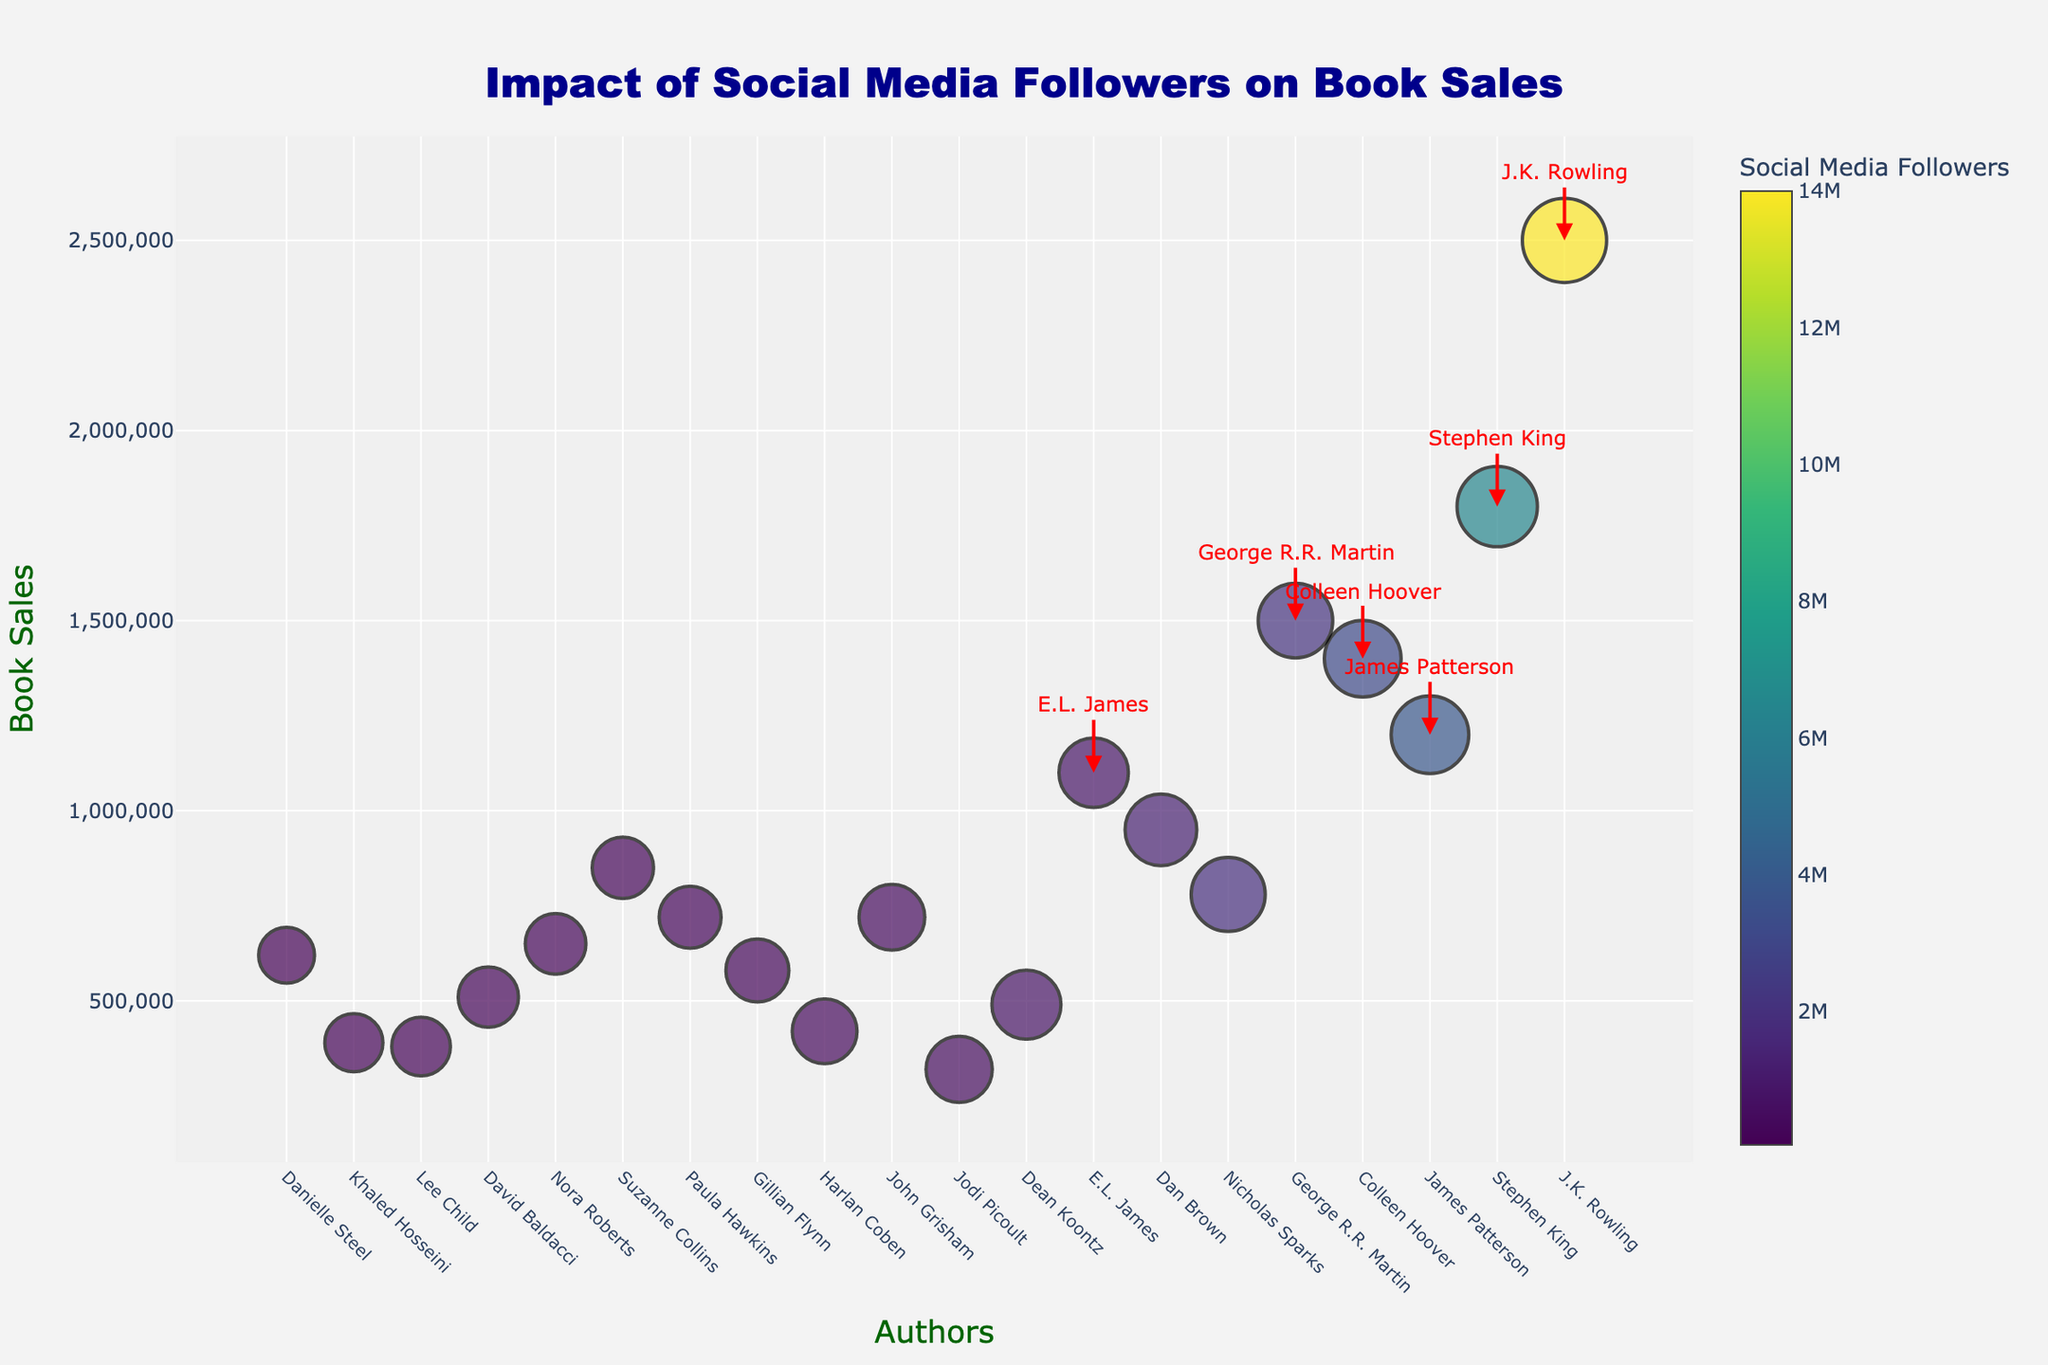What's the title of the plot? The title of the plot is displayed at the top and reads 'Impact of Social Media Followers on Book Sales'.
Answer: Impact of Social Media Followers on Book Sales How many authors have book sales over 1,000,000? To determine this, we look at data points above the 1,000,000 mark on the y-axis. These authors are highlighted with annotations. There are 7 authors with sales over 1,000,000.
Answer: 7 Which author has the highest social media follower count? The size and color intensity in the figure indicate higher social media follower counts. The author with the largest and most intense color marker, along with the highest count annotation, is J.K. Rowling.
Answer: J.K. Rowling What is the y-axis label in the plot? The label of the y-axis can be seen along the vertical axis, which reads 'Book Sales'.
Answer: Book Sales Who has higher book sales, George R.R. Martin or James Patterson? We find both authors in the plot and compare their y-axis positions. James Patterson has a lower position (1,200,000 sales) compared to George R.R. Martin (1,500,000 sales).
Answer: George R.R. Martin Which author has the largest mismatch between social media followers and book sales? To find this, we analyze authors with large bubble sizes but relatively low y-axis positions or vice versa. John Grisham stands out with significantly lower followers but relatively higher book sales.
Answer: John Grisham What color represents authors with social media followers around 1,000,000? The color scale indicator shows the distribution, and authors with around 1,000,000 followers, such as Dan Brown with 1,200,000 followers, are represented by a greenish color.
Answer: Greenish What is the approximate difference in book sales between Stephen King and Dan Brown? Stephen King's sales (1,800,000) and Dan Brown's sales (950,000). Subtracting the two gives the difference: 1,800,000 - 950,000 = 850,000.
Answer: 850,000 Identify an author with relatively low social media followers but notably high book sales. By examining the plot, Danielle Steel is identified as having lower social media followers (55,000) with higher book sales (620,000) comparatively.
Answer: Danielle Steel 